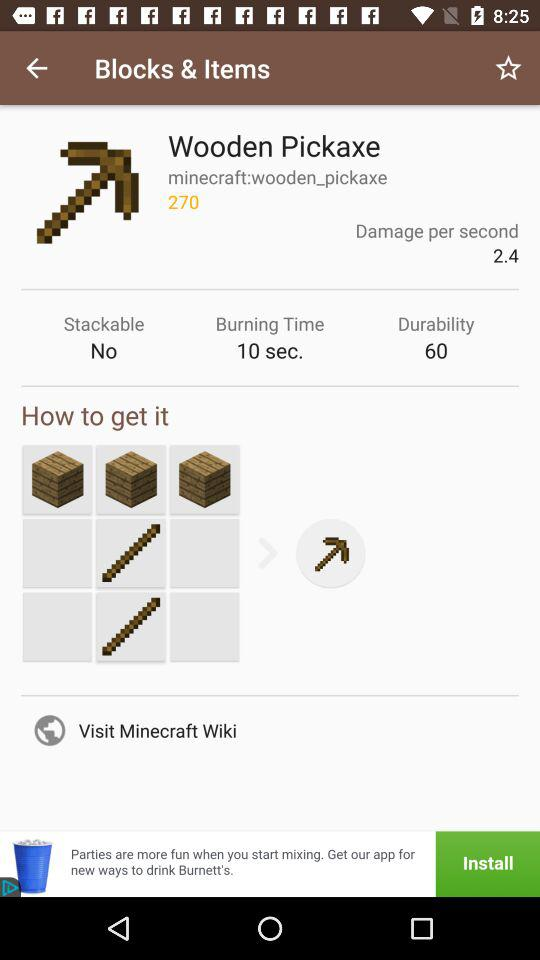What is the "Burning Time"? The "Burning Time" is 10 seconds. 